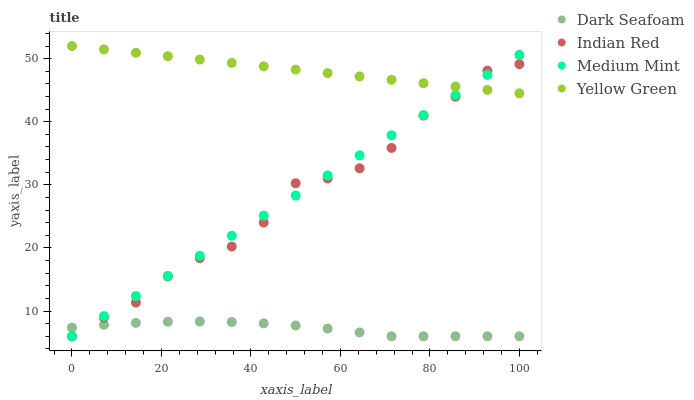Does Dark Seafoam have the minimum area under the curve?
Answer yes or no. Yes. Does Yellow Green have the maximum area under the curve?
Answer yes or no. Yes. Does Yellow Green have the minimum area under the curve?
Answer yes or no. No. Does Dark Seafoam have the maximum area under the curve?
Answer yes or no. No. Is Medium Mint the smoothest?
Answer yes or no. Yes. Is Indian Red the roughest?
Answer yes or no. Yes. Is Dark Seafoam the smoothest?
Answer yes or no. No. Is Dark Seafoam the roughest?
Answer yes or no. No. Does Medium Mint have the lowest value?
Answer yes or no. Yes. Does Yellow Green have the lowest value?
Answer yes or no. No. Does Yellow Green have the highest value?
Answer yes or no. Yes. Does Dark Seafoam have the highest value?
Answer yes or no. No. Is Dark Seafoam less than Yellow Green?
Answer yes or no. Yes. Is Yellow Green greater than Dark Seafoam?
Answer yes or no. Yes. Does Dark Seafoam intersect Medium Mint?
Answer yes or no. Yes. Is Dark Seafoam less than Medium Mint?
Answer yes or no. No. Is Dark Seafoam greater than Medium Mint?
Answer yes or no. No. Does Dark Seafoam intersect Yellow Green?
Answer yes or no. No. 